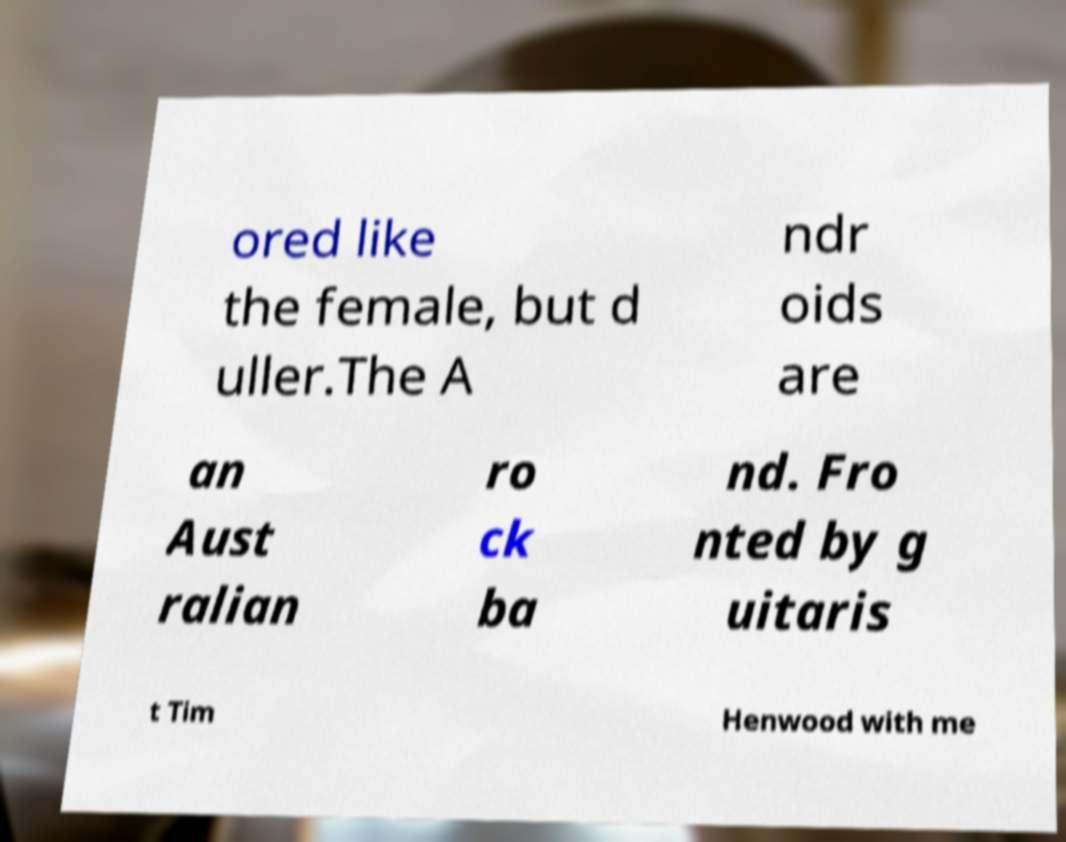Please identify and transcribe the text found in this image. ored like the female, but d uller.The A ndr oids are an Aust ralian ro ck ba nd. Fro nted by g uitaris t Tim Henwood with me 